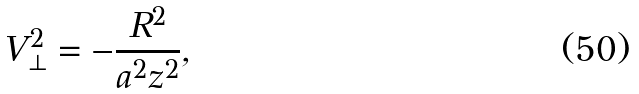Convert formula to latex. <formula><loc_0><loc_0><loc_500><loc_500>V _ { \perp } ^ { 2 } = - \frac { R ^ { 2 } } { a ^ { 2 } z ^ { 2 } } ,</formula> 